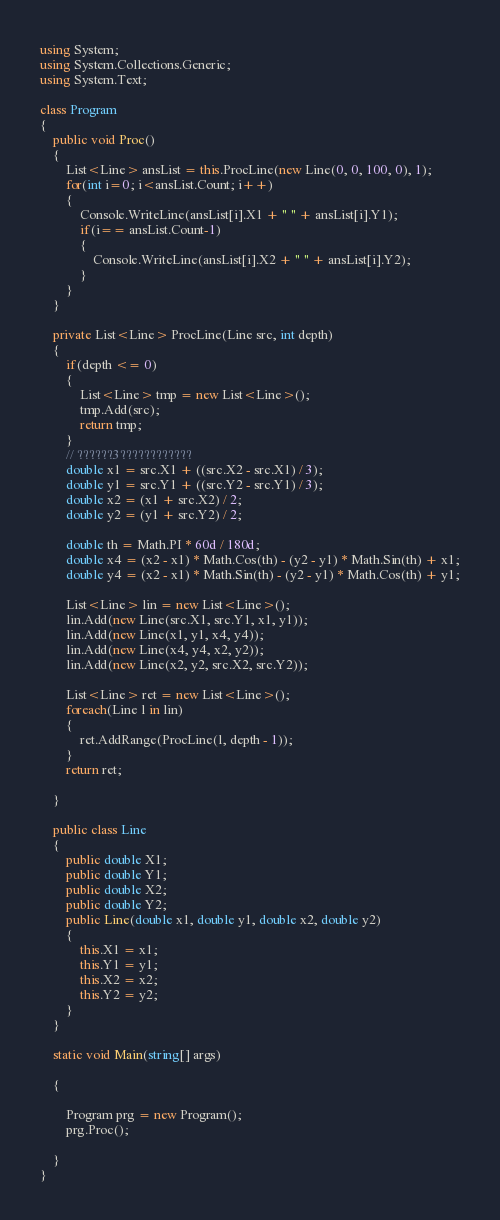<code> <loc_0><loc_0><loc_500><loc_500><_C#_>using System;
using System.Collections.Generic;
using System.Text;

class Program
{
    public void Proc()
    {
        List<Line> ansList = this.ProcLine(new Line(0, 0, 100, 0), 1);
        for(int i=0; i<ansList.Count; i++)
        {
            Console.WriteLine(ansList[i].X1 + " " + ansList[i].Y1);
            if(i== ansList.Count-1)
            {
                Console.WriteLine(ansList[i].X2 + " " + ansList[i].Y2);
            }
        }
    }

    private List<Line> ProcLine(Line src, int depth)
    {
        if(depth <= 0)
        {
            List<Line> tmp = new List<Line>();
            tmp.Add(src);
            return tmp;
        }
        // ??????3????????????
        double x1 = src.X1 + ((src.X2 - src.X1) / 3);
        double y1 = src.Y1 + ((src.Y2 - src.Y1) / 3);
        double x2 = (x1 + src.X2) / 2;
        double y2 = (y1 + src.Y2) / 2;

        double th = Math.PI * 60d / 180d;
        double x4 = (x2 - x1) * Math.Cos(th) - (y2 - y1) * Math.Sin(th) + x1;
        double y4 = (x2 - x1) * Math.Sin(th) - (y2 - y1) * Math.Cos(th) + y1;

        List<Line> lin = new List<Line>();
        lin.Add(new Line(src.X1, src.Y1, x1, y1));
        lin.Add(new Line(x1, y1, x4, y4));
        lin.Add(new Line(x4, y4, x2, y2));
        lin.Add(new Line(x2, y2, src.X2, src.Y2));

        List<Line> ret = new List<Line>();
        foreach(Line l in lin)
        {
            ret.AddRange(ProcLine(l, depth - 1));
        }
        return ret;

    }

    public class Line
    {
        public double X1;
        public double Y1;
        public double X2;
        public double Y2;
        public Line(double x1, double y1, double x2, double y2)
        {
            this.X1 = x1;
            this.Y1 = y1;
            this.X2 = x2;
            this.Y2 = y2;
        }
    }

    static void Main(string[] args)

    {

        Program prg = new Program();
        prg.Proc();

    }
}</code> 